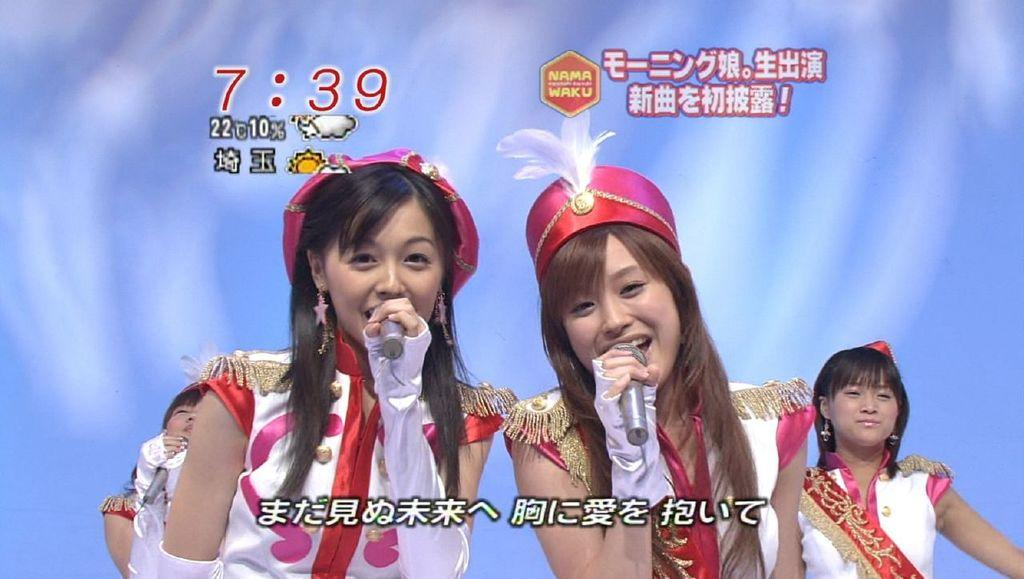What colors are used in the background of the image? The background of the picture is in blue and white colors. How many women are present in the image? There are four women in the image. What are three of the women holding in their hands? Three of the women are holding microphones in their hands. Are there any visible marks or patterns on the image? Yes, there are watermarks visible in the image. What type of wing is visible on the women in the image? There are no wings visible on the women in the image. What invention do the women in the image represent? The image does not depict any specific invention; it simply shows four women, three of whom are holding microphones. 